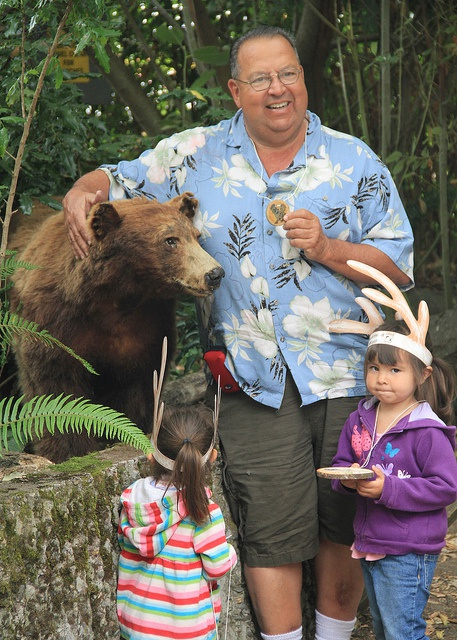Describe the objects in this image and their specific colors. I can see people in darkgreen, gray, lightblue, and lightgray tones, bear in darkgreen, black, gray, and tan tones, people in darkgreen, purple, and black tones, and people in darkgreen, lightgray, gray, lightpink, and black tones in this image. 